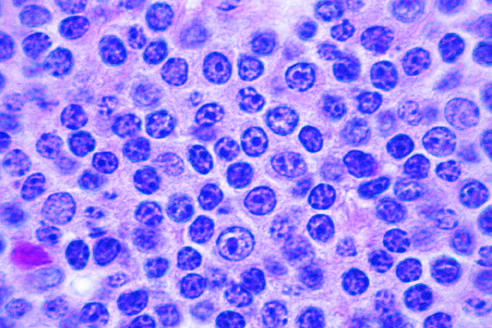do the photomicrographs have the appearance of small, round lymphocytes at high power?
Answer the question using a single word or phrase. No 